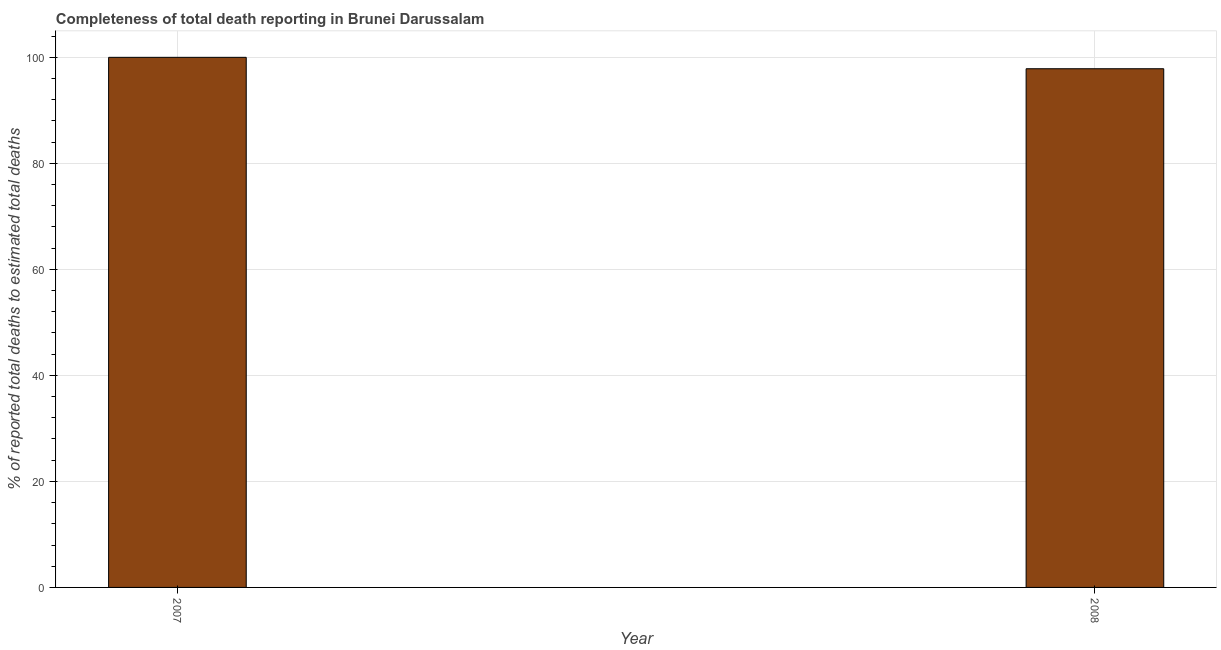What is the title of the graph?
Ensure brevity in your answer.  Completeness of total death reporting in Brunei Darussalam. What is the label or title of the Y-axis?
Give a very brief answer. % of reported total deaths to estimated total deaths. What is the completeness of total death reports in 2007?
Ensure brevity in your answer.  100. Across all years, what is the maximum completeness of total death reports?
Ensure brevity in your answer.  100. Across all years, what is the minimum completeness of total death reports?
Offer a terse response. 97.85. In which year was the completeness of total death reports minimum?
Provide a short and direct response. 2008. What is the sum of the completeness of total death reports?
Make the answer very short. 197.85. What is the difference between the completeness of total death reports in 2007 and 2008?
Ensure brevity in your answer.  2.15. What is the average completeness of total death reports per year?
Provide a succinct answer. 98.92. What is the median completeness of total death reports?
Keep it short and to the point. 98.92. In how many years, is the completeness of total death reports greater than 48 %?
Make the answer very short. 2. Do a majority of the years between 2008 and 2007 (inclusive) have completeness of total death reports greater than 76 %?
Give a very brief answer. No. What is the ratio of the completeness of total death reports in 2007 to that in 2008?
Your answer should be very brief. 1.02. Is the completeness of total death reports in 2007 less than that in 2008?
Your answer should be very brief. No. In how many years, is the completeness of total death reports greater than the average completeness of total death reports taken over all years?
Make the answer very short. 1. What is the % of reported total deaths to estimated total deaths in 2008?
Your answer should be compact. 97.85. What is the difference between the % of reported total deaths to estimated total deaths in 2007 and 2008?
Provide a short and direct response. 2.15. 